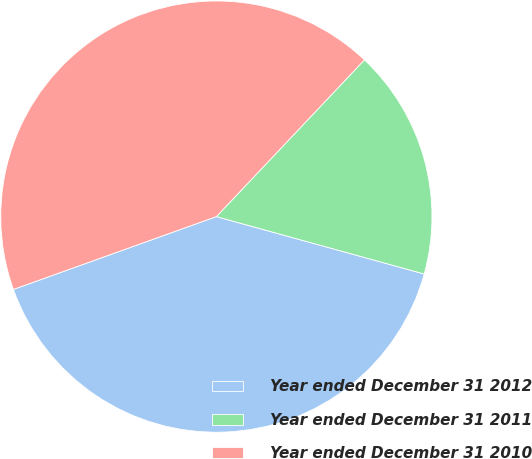Convert chart to OTSL. <chart><loc_0><loc_0><loc_500><loc_500><pie_chart><fcel>Year ended December 31 2012<fcel>Year ended December 31 2011<fcel>Year ended December 31 2010<nl><fcel>40.23%<fcel>17.24%<fcel>42.53%<nl></chart> 